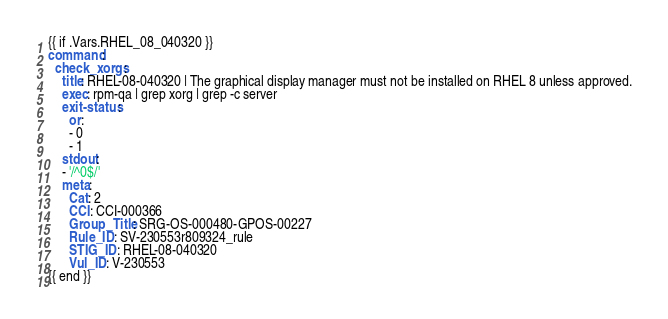Convert code to text. <code><loc_0><loc_0><loc_500><loc_500><_YAML_>{{ if .Vars.RHEL_08_040320 }}
command:
  check_xorgs:
    title: RHEL-08-040320 | The graphical display manager must not be installed on RHEL 8 unless approved.
    exec: rpm-qa | grep xorg | grep -c server
    exit-status:
      or:
      - 0
      - 1
    stdout:
    - '/^0$/'
    meta:
      Cat: 2
      CCI: CCI-000366
      Group_Title: SRG-OS-000480-GPOS-00227
      Rule_ID: SV-230553r809324_rule
      STIG_ID: RHEL-08-040320
      Vul_ID: V-230553
{{ end }}</code> 